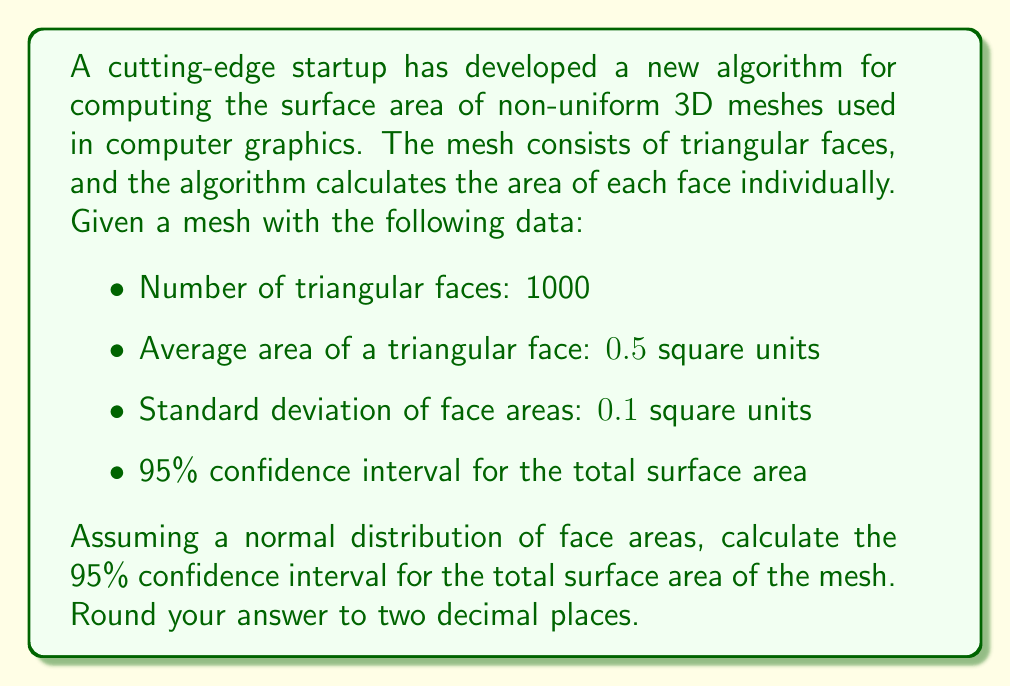Can you solve this math problem? To solve this problem, we'll follow these steps:

1) First, let's calculate the total surface area:
   $$\text{Total Area} = \text{Number of faces} \times \text{Average area per face}$$
   $$\text{Total Area} = 1000 \times 0.5 = 500 \text{ square units}$$

2) Now, we need to find the standard error of the mean (SEM) for the total area. The formula for SEM is:
   $$\text{SEM} = \frac{\sigma}{\sqrt{n}}$$
   where $\sigma$ is the standard deviation and $n$ is the sample size (number of faces).

3) In this case:
   $$\text{SEM} = \frac{0.1}{\sqrt{1000}} = 0.00316227766$$

4) For a 95% confidence interval, we use 1.96 as our z-score (assuming a normal distribution). The formula for the confidence interval is:
   $$\text{CI} = \text{Mean} \pm (z \times \text{SEM})$$

5) Therefore, our confidence interval is:
   $$500 \pm (1.96 \times 0.00316227766 \times 1000)$$
   $$500 \pm 6.198$$

6) This gives us a range of:
   $$493.802 \text{ to } 506.198 \text{ square units}$$

7) Rounding to two decimal places:
   $$493.80 \text{ to } 506.20 \text{ square units}$$
Answer: The 95% confidence interval for the total surface area of the mesh is 493.80 to 506.20 square units. 